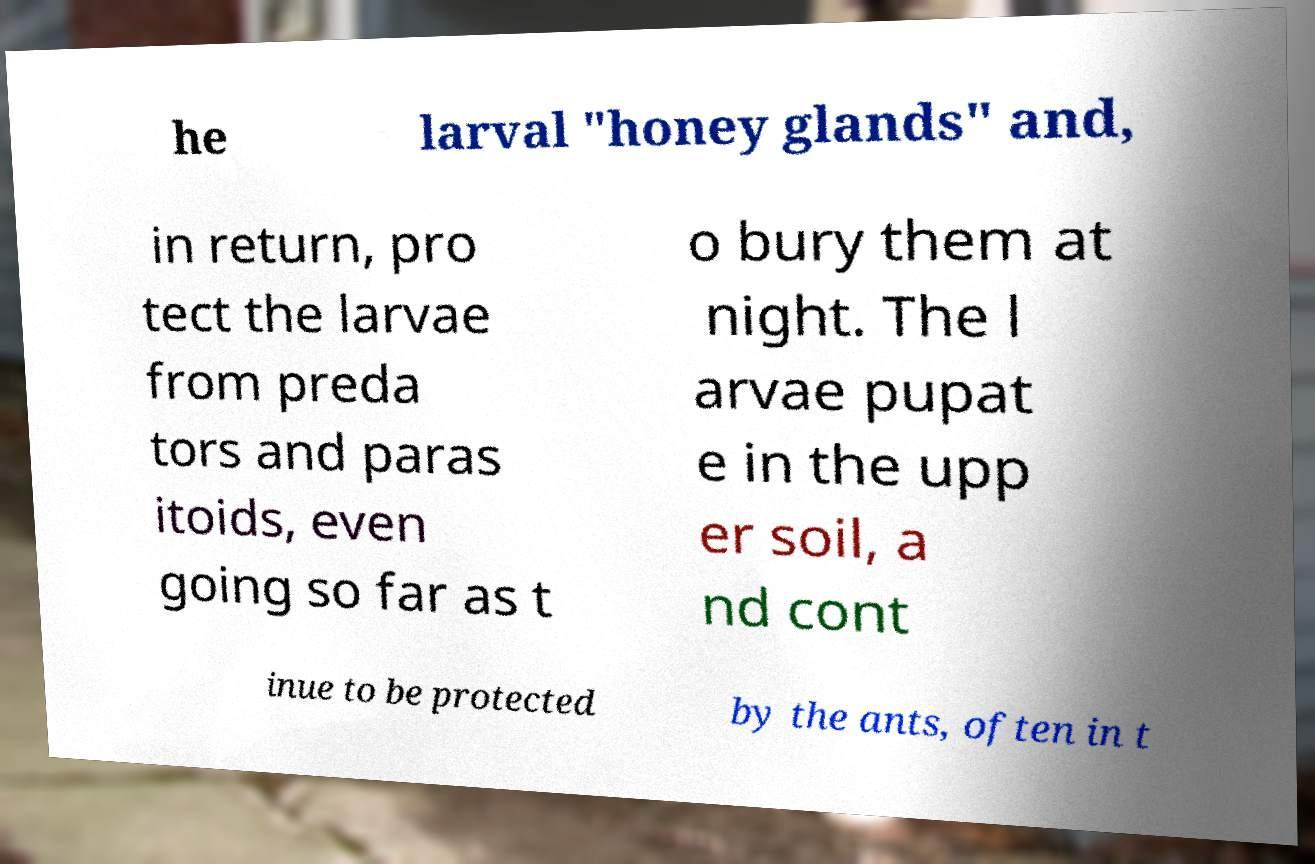I need the written content from this picture converted into text. Can you do that? he larval "honey glands" and, in return, pro tect the larvae from preda tors and paras itoids, even going so far as t o bury them at night. The l arvae pupat e in the upp er soil, a nd cont inue to be protected by the ants, often in t 